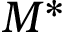Convert formula to latex. <formula><loc_0><loc_0><loc_500><loc_500>M ^ { * }</formula> 